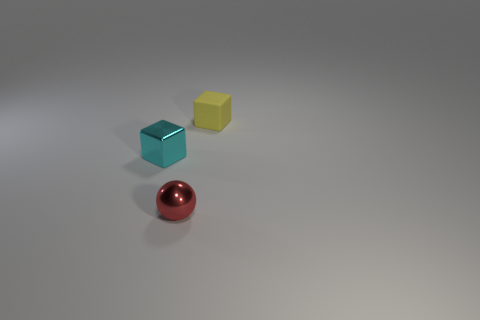There is a small object in front of the tiny cyan shiny thing; what material is it?
Make the answer very short. Metal. Do the cube that is right of the cyan shiny thing and the small cube that is left of the red sphere have the same material?
Make the answer very short. No. Is there a small red thing made of the same material as the cyan thing?
Make the answer very short. Yes. What is the shape of the tiny red object?
Offer a terse response. Sphere. What color is the other thing that is made of the same material as the small red object?
Provide a short and direct response. Cyan. How many red objects are metallic cubes or shiny objects?
Your response must be concise. 1. Are there more small yellow rubber cubes than small metallic cylinders?
Your answer should be compact. Yes. How many objects are small cubes that are behind the small shiny cube or tiny things on the left side of the tiny matte block?
Provide a succinct answer. 3. What color is the matte block that is the same size as the red shiny sphere?
Offer a terse response. Yellow. Is the tiny cyan cube made of the same material as the red sphere?
Your answer should be compact. Yes. 